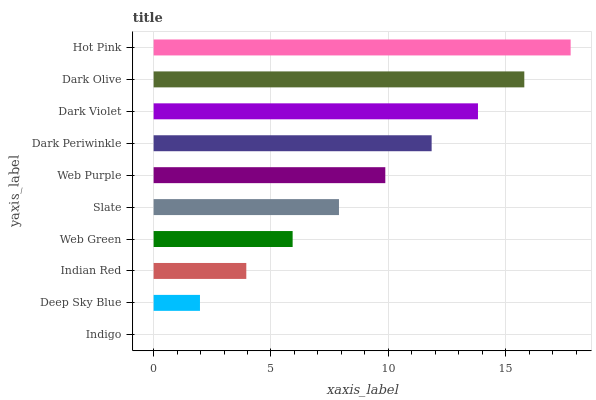Is Indigo the minimum?
Answer yes or no. Yes. Is Hot Pink the maximum?
Answer yes or no. Yes. Is Deep Sky Blue the minimum?
Answer yes or no. No. Is Deep Sky Blue the maximum?
Answer yes or no. No. Is Deep Sky Blue greater than Indigo?
Answer yes or no. Yes. Is Indigo less than Deep Sky Blue?
Answer yes or no. Yes. Is Indigo greater than Deep Sky Blue?
Answer yes or no. No. Is Deep Sky Blue less than Indigo?
Answer yes or no. No. Is Web Purple the high median?
Answer yes or no. Yes. Is Slate the low median?
Answer yes or no. Yes. Is Indian Red the high median?
Answer yes or no. No. Is Web Green the low median?
Answer yes or no. No. 